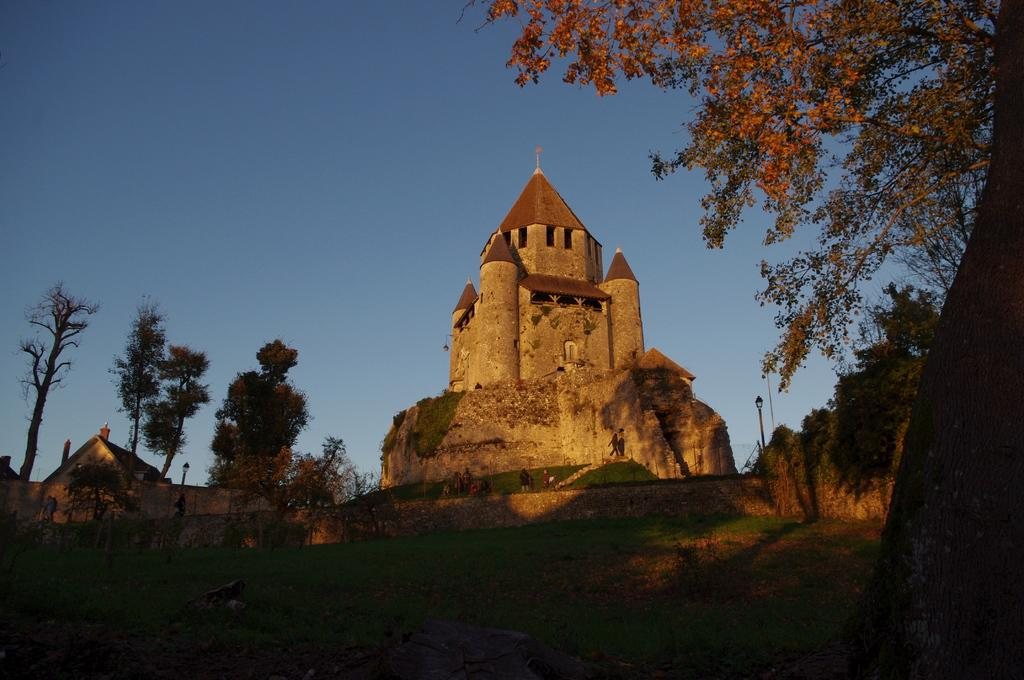What is the main structure in the image? There is a castle in the image. What type of vegetation surrounds the castle? Trees are present on either side of the castle. What other building can be seen in the image? There is a building on the left side of the image. What is visible above the castle? The sky is visible above the castle. What type of fowl is participating in the competition in the image? There is no competition or fowl present in the image; it features a castle with trees and a building. 